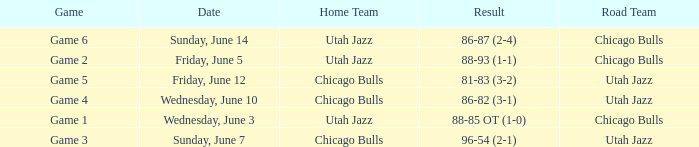Game of game 5 had what result? 81-83 (3-2). 